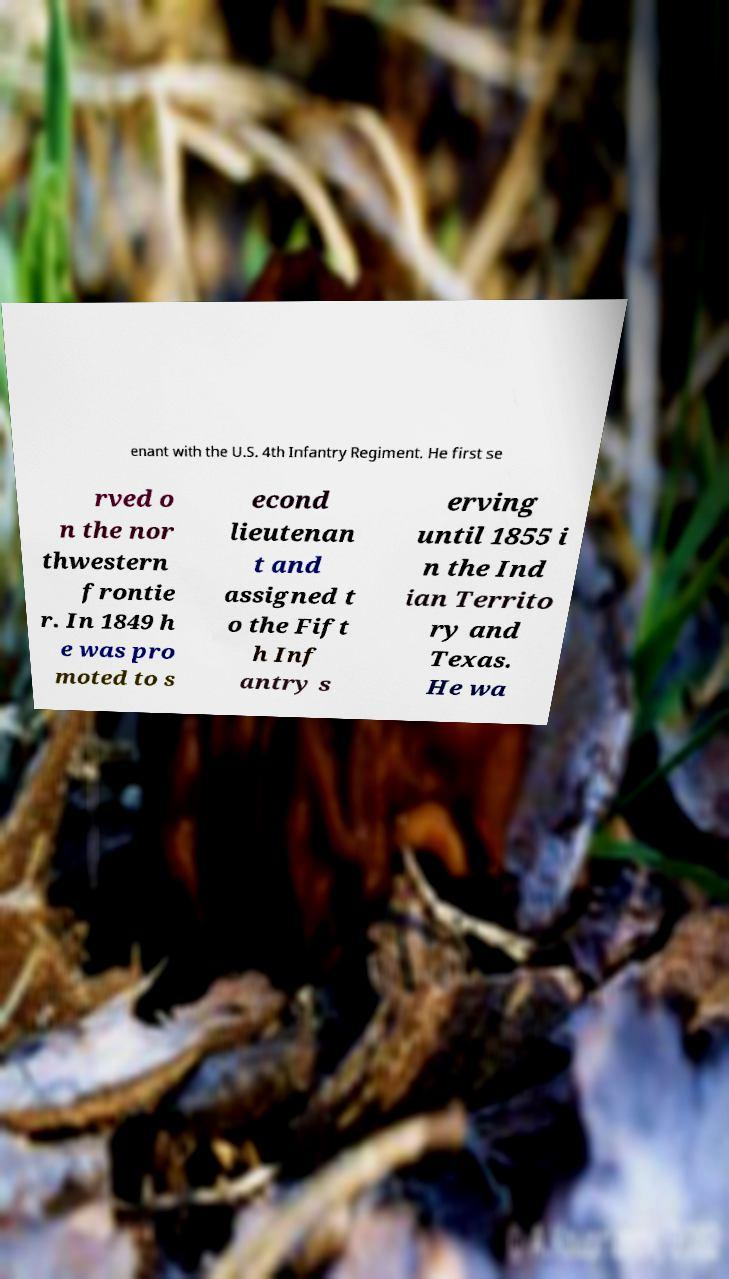I need the written content from this picture converted into text. Can you do that? enant with the U.S. 4th Infantry Regiment. He first se rved o n the nor thwestern frontie r. In 1849 h e was pro moted to s econd lieutenan t and assigned t o the Fift h Inf antry s erving until 1855 i n the Ind ian Territo ry and Texas. He wa 